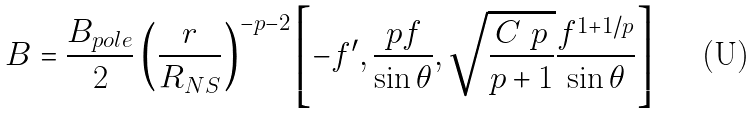Convert formula to latex. <formula><loc_0><loc_0><loc_500><loc_500>\ B = \frac { B _ { p o l e } } { 2 } \left ( \frac { r } { R _ { N S } } \right ) ^ { - p - 2 } \left [ - f ^ { \prime } , \frac { p f } { \sin \theta } , \sqrt { \frac { C \ p } { p + 1 } } \frac { f ^ { 1 + 1 / p } } { \sin \theta } \right ]</formula> 